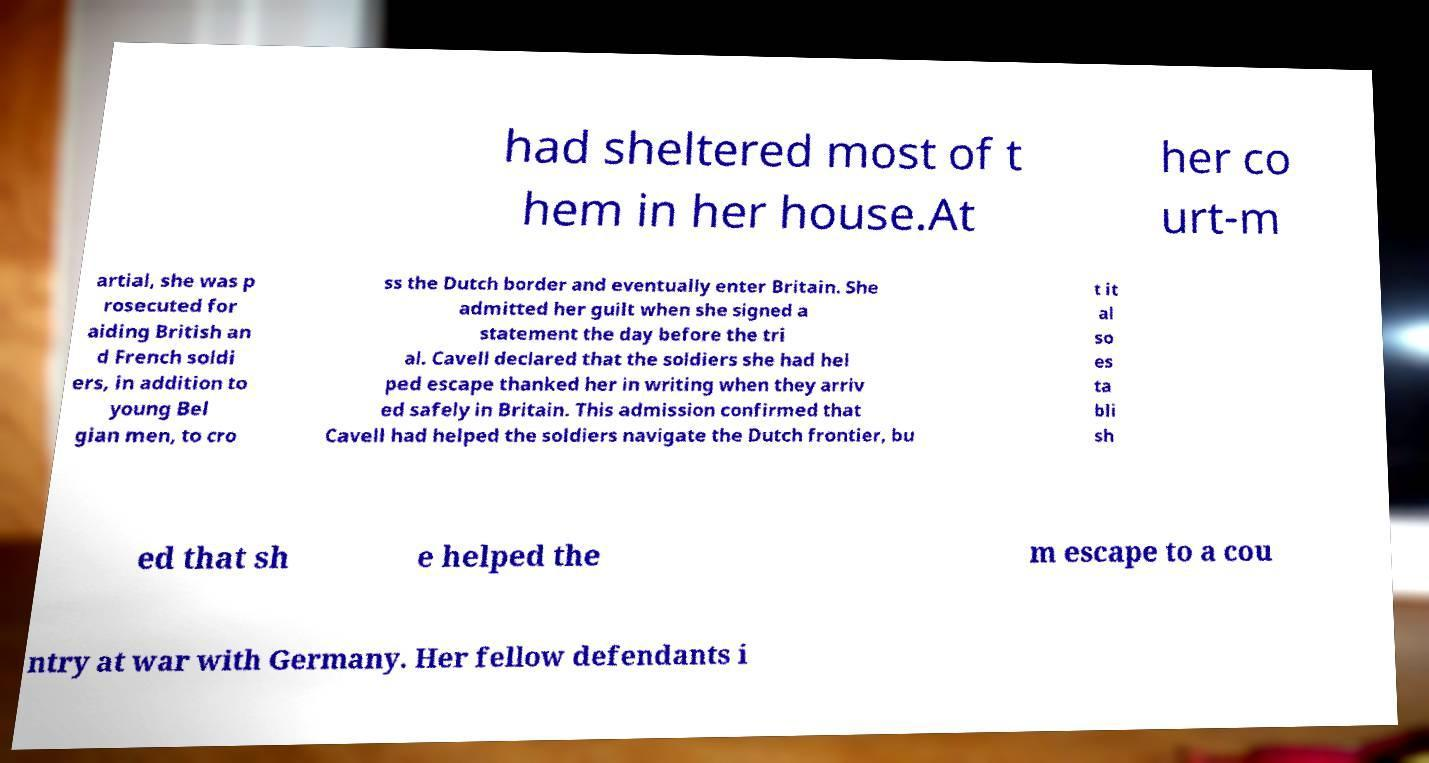There's text embedded in this image that I need extracted. Can you transcribe it verbatim? had sheltered most of t hem in her house.At her co urt-m artial, she was p rosecuted for aiding British an d French soldi ers, in addition to young Bel gian men, to cro ss the Dutch border and eventually enter Britain. She admitted her guilt when she signed a statement the day before the tri al. Cavell declared that the soldiers she had hel ped escape thanked her in writing when they arriv ed safely in Britain. This admission confirmed that Cavell had helped the soldiers navigate the Dutch frontier, bu t it al so es ta bli sh ed that sh e helped the m escape to a cou ntry at war with Germany. Her fellow defendants i 